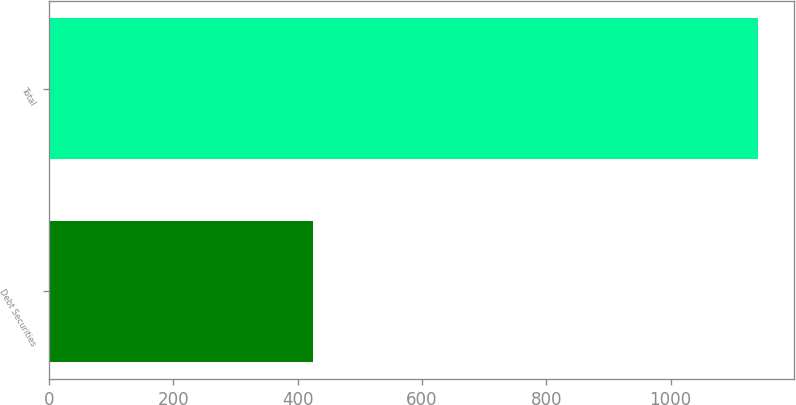Convert chart. <chart><loc_0><loc_0><loc_500><loc_500><bar_chart><fcel>Debt Securities<fcel>Total<nl><fcel>424.8<fcel>1140.7<nl></chart> 